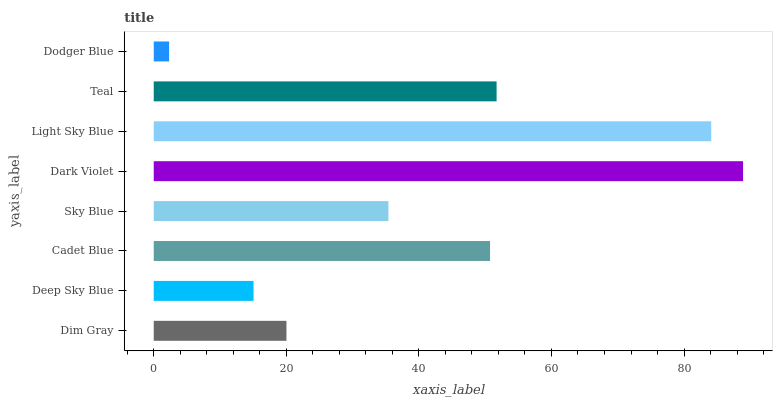Is Dodger Blue the minimum?
Answer yes or no. Yes. Is Dark Violet the maximum?
Answer yes or no. Yes. Is Deep Sky Blue the minimum?
Answer yes or no. No. Is Deep Sky Blue the maximum?
Answer yes or no. No. Is Dim Gray greater than Deep Sky Blue?
Answer yes or no. Yes. Is Deep Sky Blue less than Dim Gray?
Answer yes or no. Yes. Is Deep Sky Blue greater than Dim Gray?
Answer yes or no. No. Is Dim Gray less than Deep Sky Blue?
Answer yes or no. No. Is Cadet Blue the high median?
Answer yes or no. Yes. Is Sky Blue the low median?
Answer yes or no. Yes. Is Dim Gray the high median?
Answer yes or no. No. Is Dodger Blue the low median?
Answer yes or no. No. 